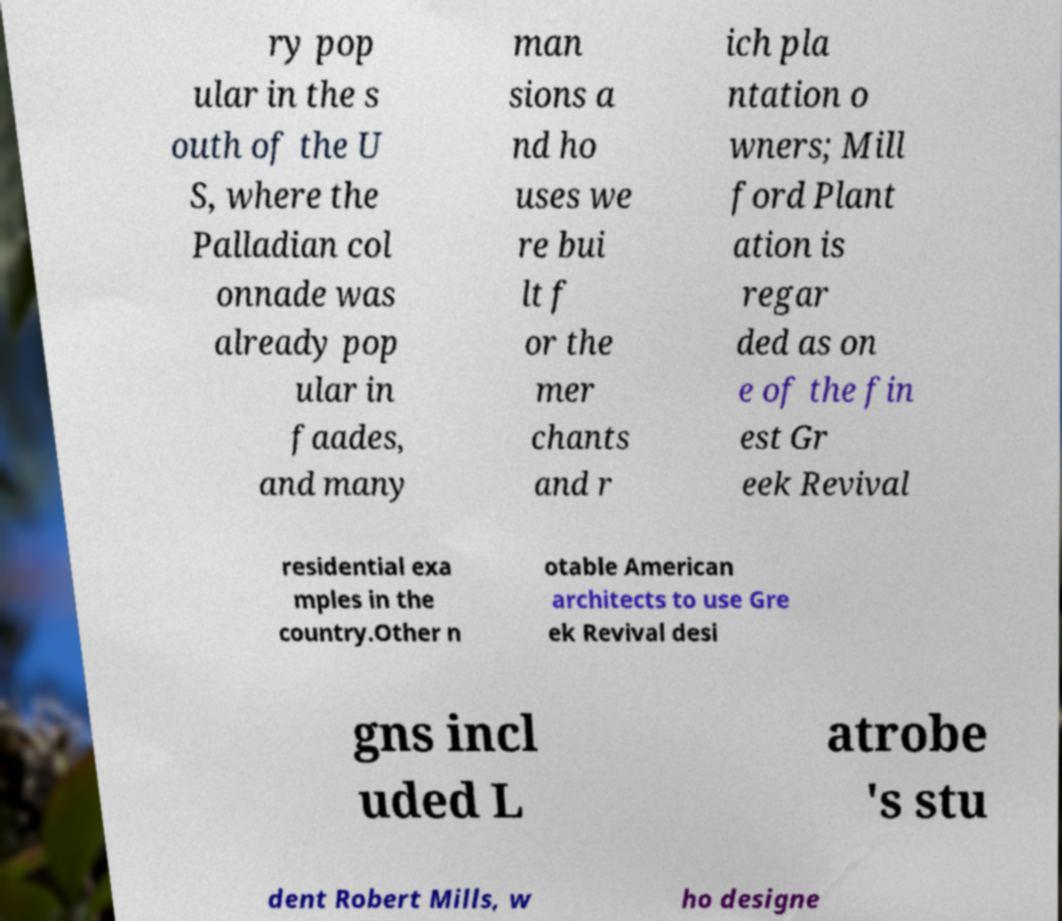There's text embedded in this image that I need extracted. Can you transcribe it verbatim? ry pop ular in the s outh of the U S, where the Palladian col onnade was already pop ular in faades, and many man sions a nd ho uses we re bui lt f or the mer chants and r ich pla ntation o wners; Mill ford Plant ation is regar ded as on e of the fin est Gr eek Revival residential exa mples in the country.Other n otable American architects to use Gre ek Revival desi gns incl uded L atrobe 's stu dent Robert Mills, w ho designe 